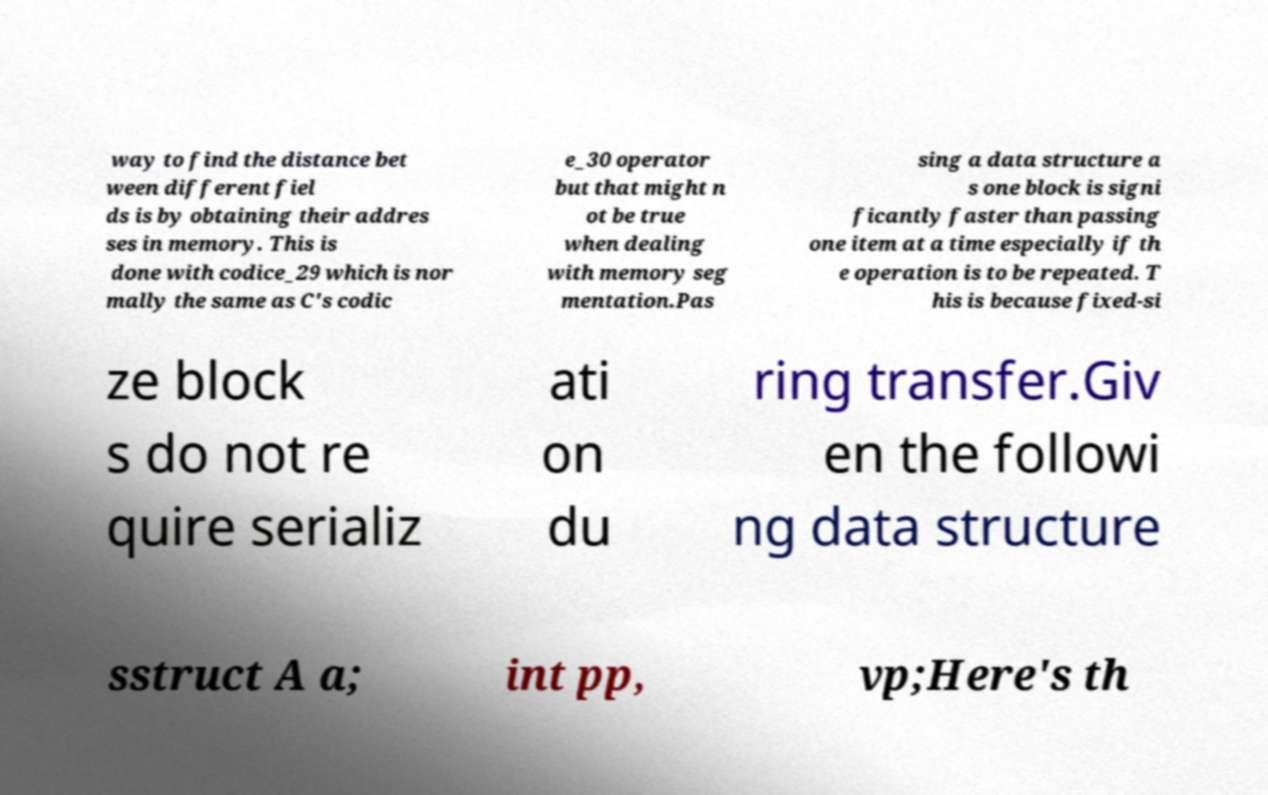I need the written content from this picture converted into text. Can you do that? way to find the distance bet ween different fiel ds is by obtaining their addres ses in memory. This is done with codice_29 which is nor mally the same as C's codic e_30 operator but that might n ot be true when dealing with memory seg mentation.Pas sing a data structure a s one block is signi ficantly faster than passing one item at a time especially if th e operation is to be repeated. T his is because fixed-si ze block s do not re quire serializ ati on du ring transfer.Giv en the followi ng data structure sstruct A a; int pp, vp;Here's th 